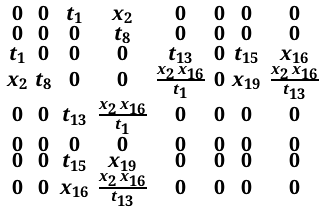Convert formula to latex. <formula><loc_0><loc_0><loc_500><loc_500>\begin{smallmatrix} 0 & 0 & { t _ { 1 } } & { x _ { 2 } } & 0 & 0 & 0 & 0 \\ 0 & 0 & 0 & { t _ { 8 } } & 0 & 0 & 0 & 0 \\ { t _ { 1 } } & 0 & 0 & 0 & { t _ { 1 3 } } & 0 & { t _ { 1 5 } } & { x _ { 1 6 } } \\ { x _ { 2 } } & { t _ { 8 } } & 0 & 0 & { \frac { { x _ { 2 } } \, { x _ { 1 6 } } } { { t _ { 1 } } } } & 0 & { x _ { 1 9 } } & { \frac { { x _ { 2 } } \, { x _ { 1 6 } } } { { t _ { 1 3 } } } } \\ 0 & 0 & { t _ { 1 3 } } & { \frac { { x _ { 2 } } \, { x _ { 1 6 } } } { { t _ { 1 } } } } & 0 & 0 & 0 & 0 \\ 0 & 0 & 0 & 0 & 0 & 0 & 0 & 0 \\ 0 & 0 & { t _ { 1 5 } } & { x _ { 1 9 } } & 0 & 0 & 0 & 0 \\ 0 & 0 & { x _ { 1 6 } } & { \frac { { x _ { 2 } } \, { x _ { 1 6 } } } { { t _ { 1 3 } } } } & 0 & 0 & 0 & 0 \end{smallmatrix}</formula> 